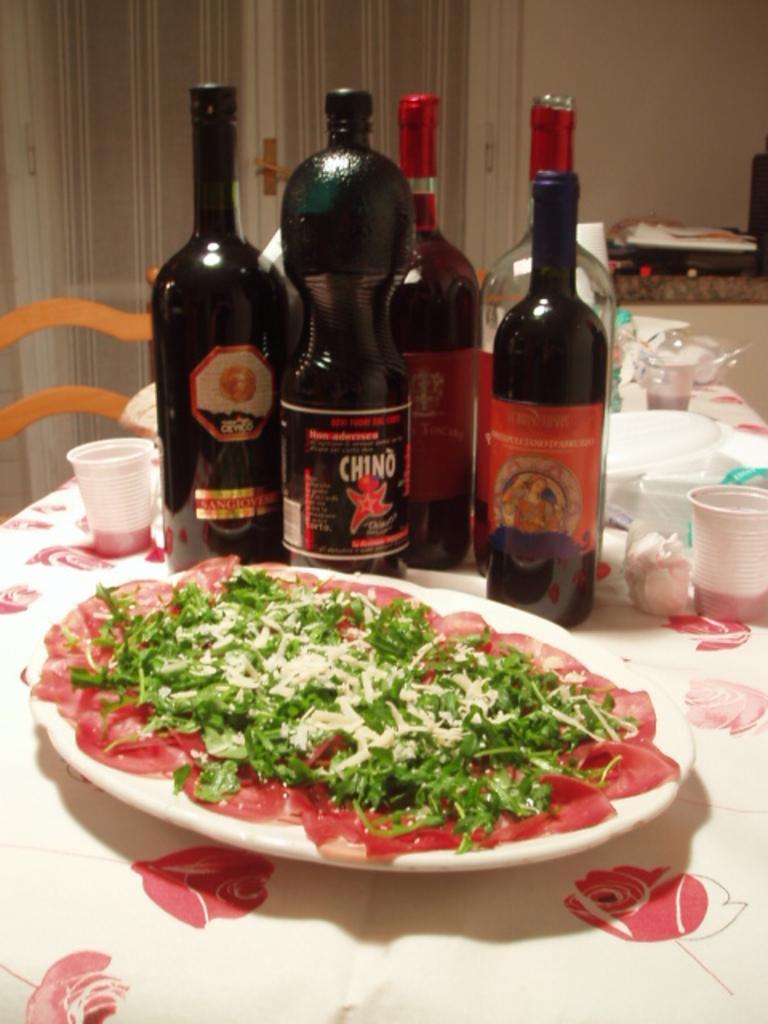Can you describe this image briefly? In this image at the bottom there is one table, on the table there is some plate, bottles, cups, glasses. And in the plates there is some food, and in the background there is one chair and some objects, wall and door. 